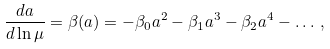<formula> <loc_0><loc_0><loc_500><loc_500>\frac { d a } { d \ln \mu } = \beta ( a ) = - \beta _ { 0 } a ^ { 2 } - \beta _ { 1 } a ^ { 3 } - \beta _ { 2 } a ^ { 4 } - \dots \, ,</formula> 